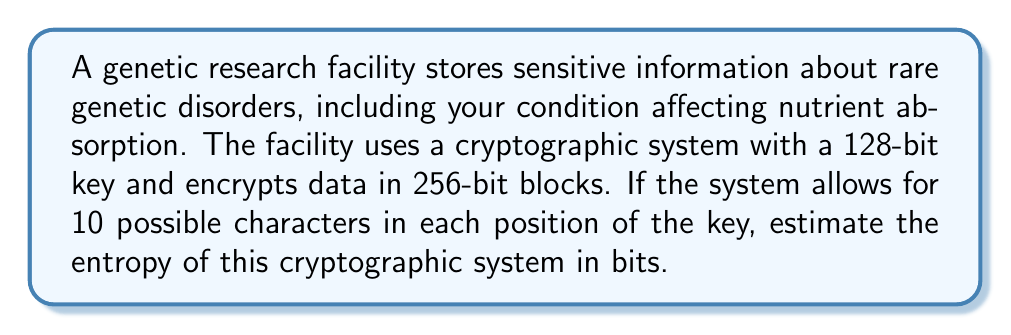Provide a solution to this math problem. To estimate the entropy of this cryptographic system, we'll follow these steps:

1) First, we need to calculate the number of possible keys. With 128 bits and 10 possible characters for each position, we have:

   $$ N = 10^{128} $$

2) The entropy of a system is typically measured in bits and is calculated using the formula:

   $$ H = \log_2(N) $$

   Where $N$ is the number of possible outcomes (in this case, the number of possible keys).

3) Substituting our value for $N$:

   $$ H = \log_2(10^{128}) $$

4) Using the logarithm property $\log_a(x^n) = n\log_a(x)$, we can simplify:

   $$ H = 128 \log_2(10) $$

5) $\log_2(10)$ is approximately 3.32193, so:

   $$ H \approx 128 * 3.32193 \approx 425.21 \text{ bits} $$

Therefore, the estimated entropy of this cryptographic system is about 425 bits.
Answer: 425 bits 